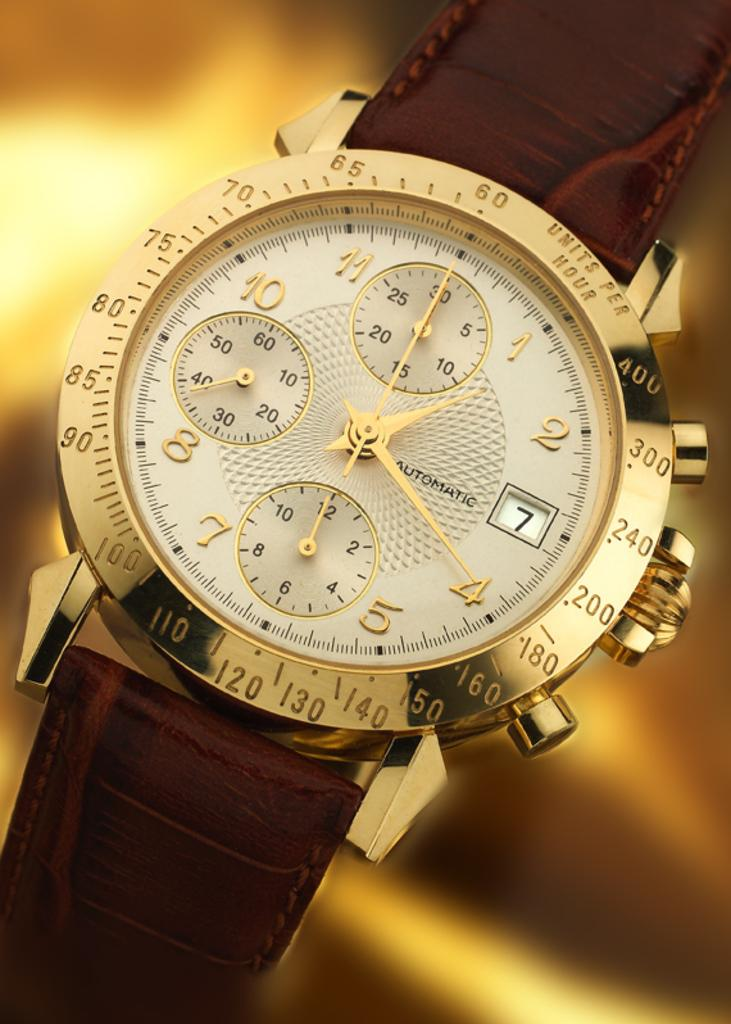Provide a one-sentence caption for the provided image. A watch with a leather band displays the day of the month as the 7th. 